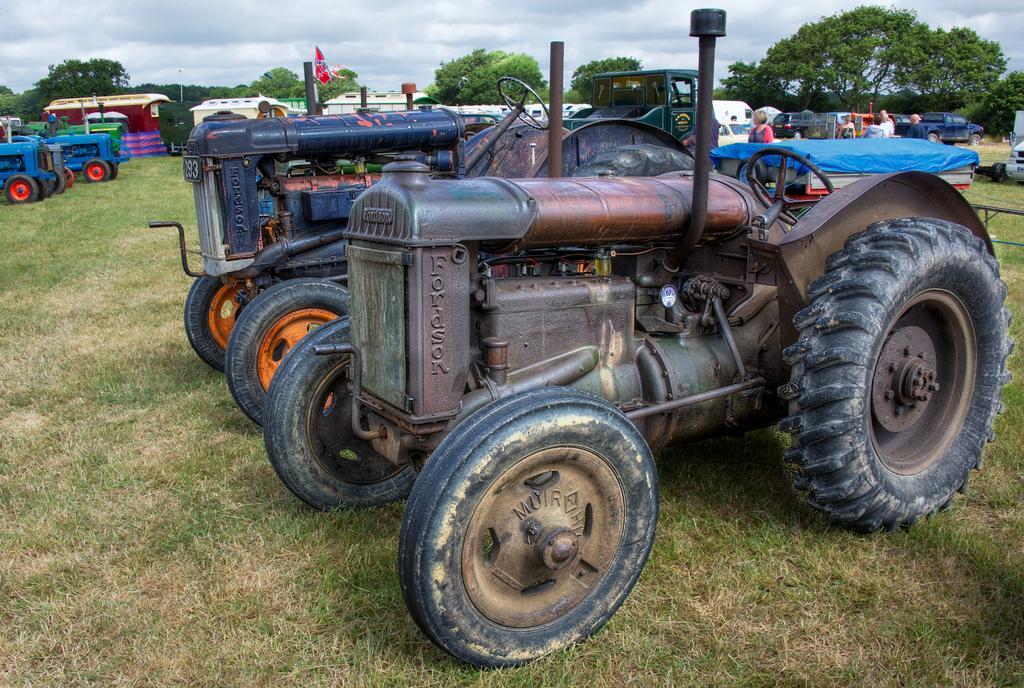Describe this image in one or two sentences. On the right side, there are tractors parked on the grass on the ground. In the background, there are vehicles, persons, trees and there are clouds in the sky. 